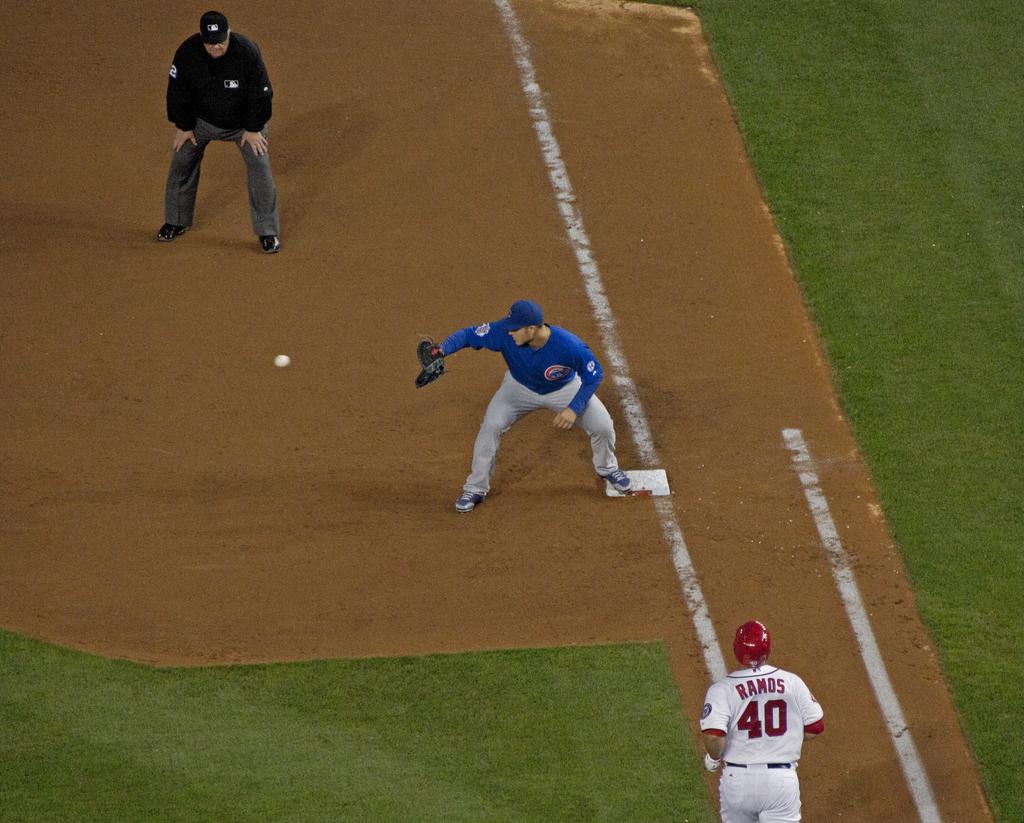What is the players name heading to base?
Keep it short and to the point. Ramos. 